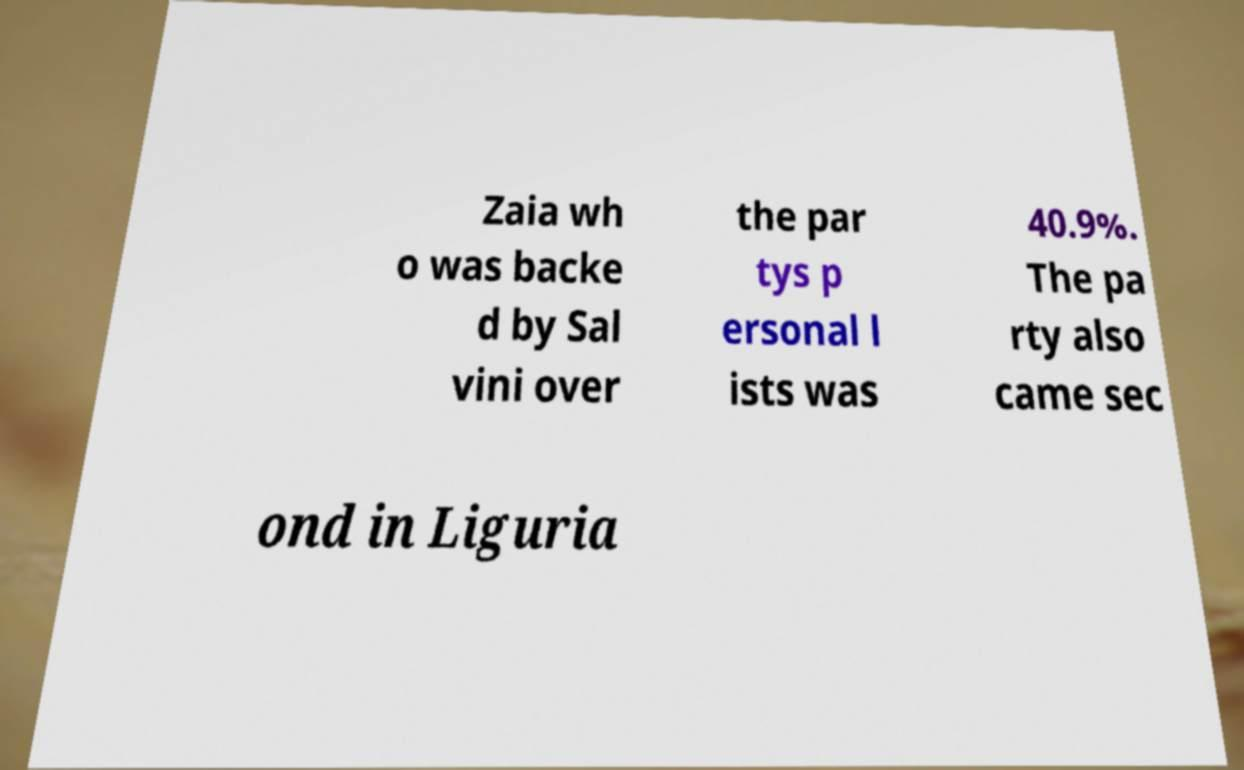For documentation purposes, I need the text within this image transcribed. Could you provide that? Zaia wh o was backe d by Sal vini over the par tys p ersonal l ists was 40.9%. The pa rty also came sec ond in Liguria 